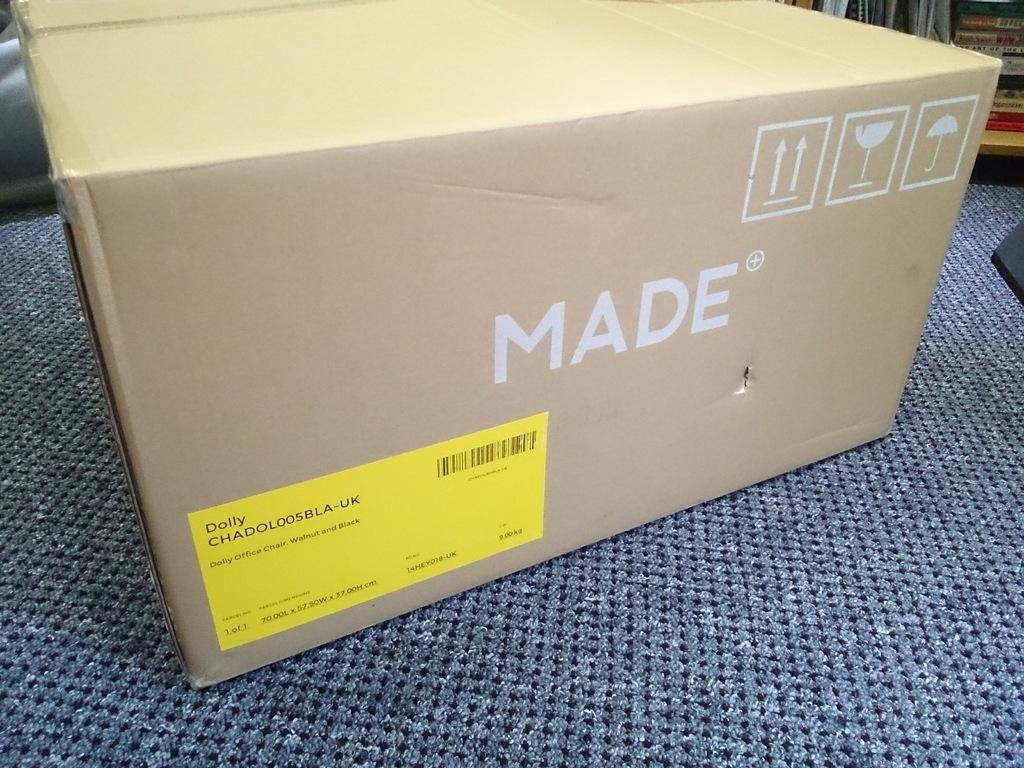<image>
Give a short and clear explanation of the subsequent image. A beige box that is by a brand called Made. 